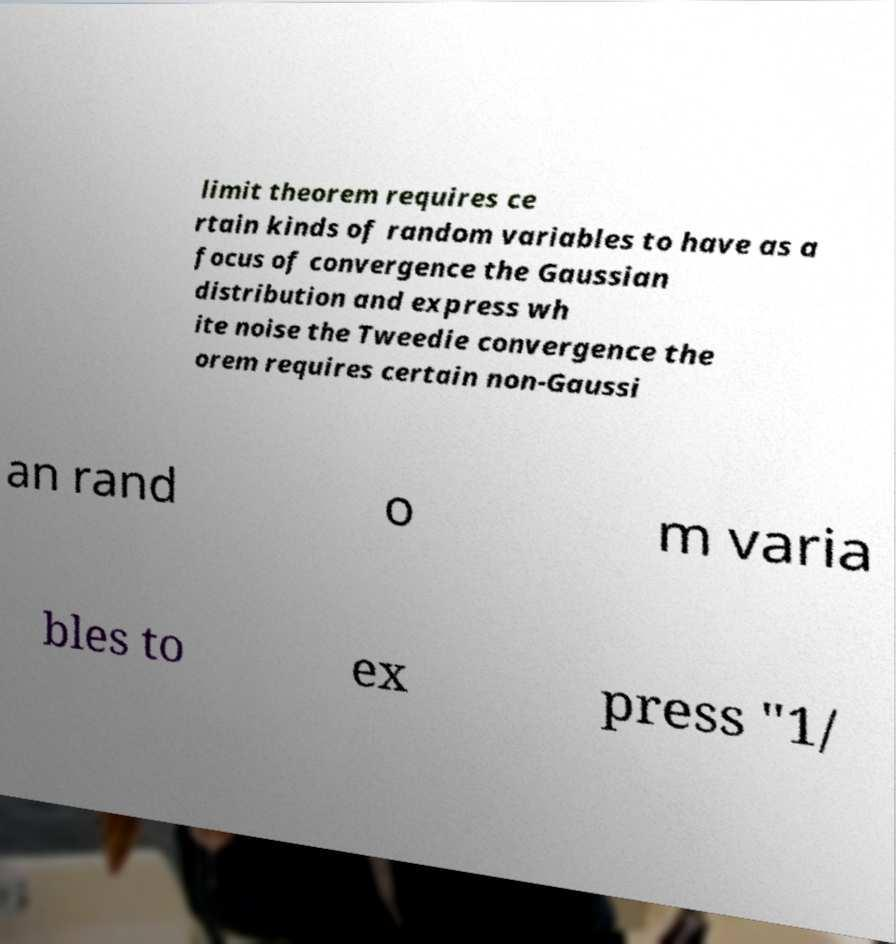Please read and relay the text visible in this image. What does it say? limit theorem requires ce rtain kinds of random variables to have as a focus of convergence the Gaussian distribution and express wh ite noise the Tweedie convergence the orem requires certain non-Gaussi an rand o m varia bles to ex press "1/ 